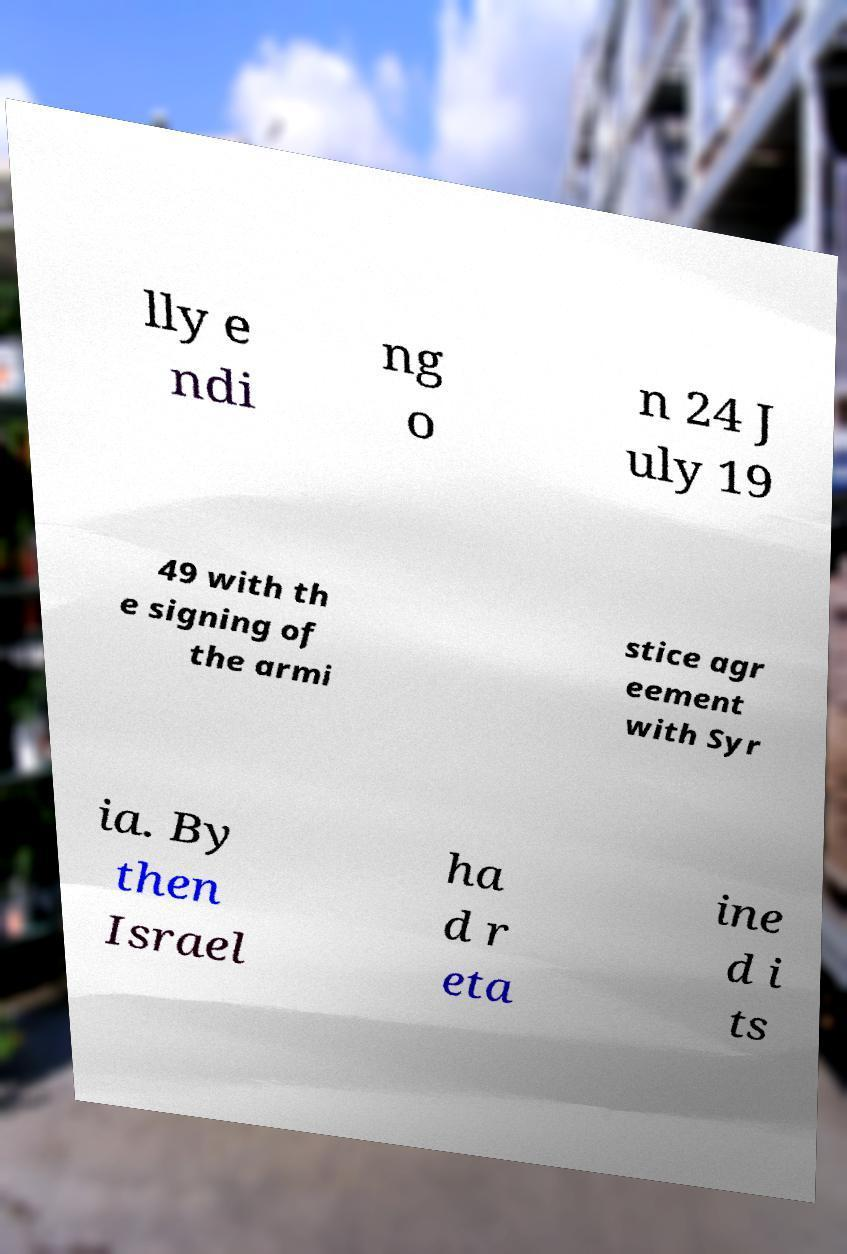Can you accurately transcribe the text from the provided image for me? lly e ndi ng o n 24 J uly 19 49 with th e signing of the armi stice agr eement with Syr ia. By then Israel ha d r eta ine d i ts 